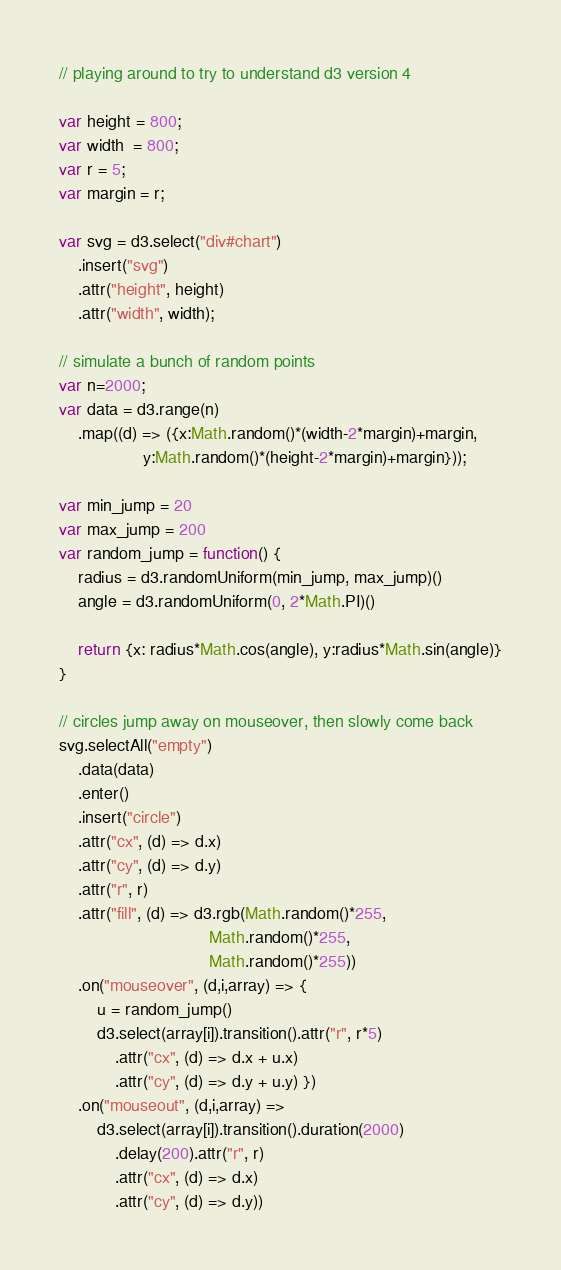<code> <loc_0><loc_0><loc_500><loc_500><_JavaScript_>// playing around to try to understand d3 version 4

var height = 800;
var width  = 800;
var r = 5;
var margin = r;

var svg = d3.select("div#chart")
    .insert("svg")
    .attr("height", height)
    .attr("width", width);

// simulate a bunch of random points
var n=2000;
var data = d3.range(n)
    .map((d) => ({x:Math.random()*(width-2*margin)+margin,
                  y:Math.random()*(height-2*margin)+margin}));

var min_jump = 20
var max_jump = 200
var random_jump = function() {
    radius = d3.randomUniform(min_jump, max_jump)()
    angle = d3.randomUniform(0, 2*Math.PI)()

    return {x: radius*Math.cos(angle), y:radius*Math.sin(angle)}
}

// circles jump away on mouseover, then slowly come back
svg.selectAll("empty")
    .data(data)
    .enter()
    .insert("circle")
    .attr("cx", (d) => d.x)
    .attr("cy", (d) => d.y)
    .attr("r", r)
    .attr("fill", (d) => d3.rgb(Math.random()*255,
                                Math.random()*255,
                                Math.random()*255))
    .on("mouseover", (d,i,array) => {
        u = random_jump()
        d3.select(array[i]).transition().attr("r", r*5)
            .attr("cx", (d) => d.x + u.x)
            .attr("cy", (d) => d.y + u.y) })
    .on("mouseout", (d,i,array) =>
        d3.select(array[i]).transition().duration(2000)
            .delay(200).attr("r", r)
            .attr("cx", (d) => d.x)
            .attr("cy", (d) => d.y))
</code> 